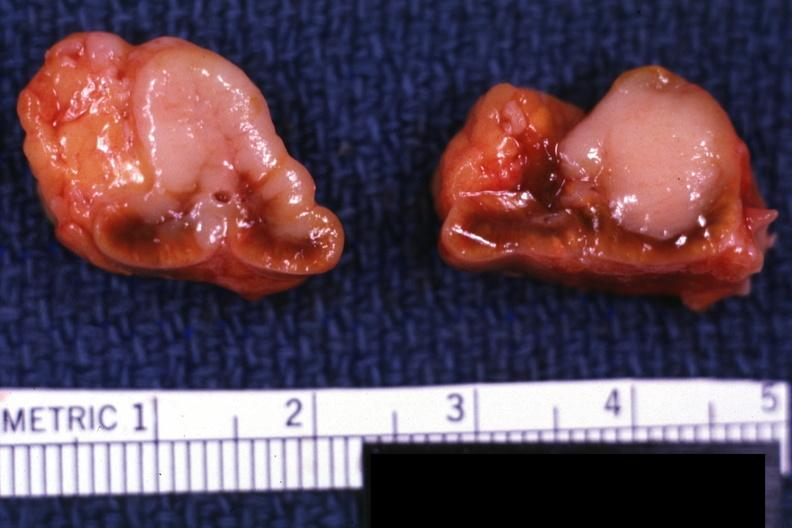what is primary 6911 and bone metastatsis?
Answer the question using a single word or phrase. Slide 